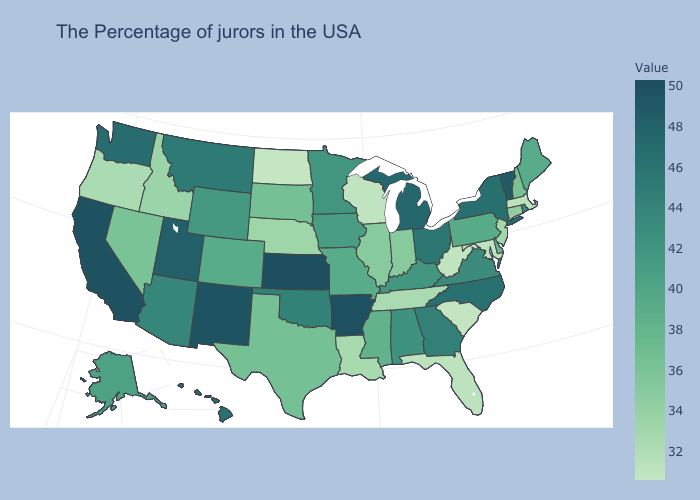Which states have the lowest value in the West?
Write a very short answer. Oregon. Among the states that border Colorado , which have the lowest value?
Give a very brief answer. Nebraska. Does the map have missing data?
Quick response, please. No. Which states have the lowest value in the USA?
Write a very short answer. North Dakota. Among the states that border Massachusetts , does New York have the lowest value?
Short answer required. No. Does Arkansas have the highest value in the South?
Be succinct. Yes. Does Kentucky have a higher value than Kansas?
Answer briefly. No. Among the states that border California , does Arizona have the highest value?
Answer briefly. Yes. Which states hav the highest value in the MidWest?
Quick response, please. Kansas. 